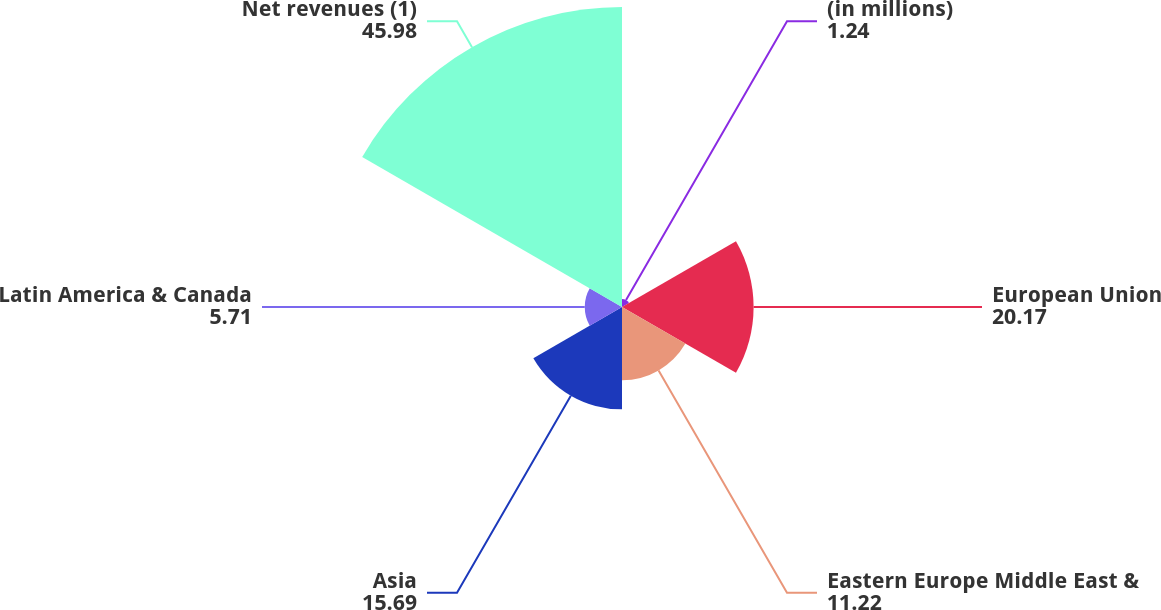Convert chart. <chart><loc_0><loc_0><loc_500><loc_500><pie_chart><fcel>(in millions)<fcel>European Union<fcel>Eastern Europe Middle East &<fcel>Asia<fcel>Latin America & Canada<fcel>Net revenues (1)<nl><fcel>1.24%<fcel>20.17%<fcel>11.22%<fcel>15.69%<fcel>5.71%<fcel>45.98%<nl></chart> 